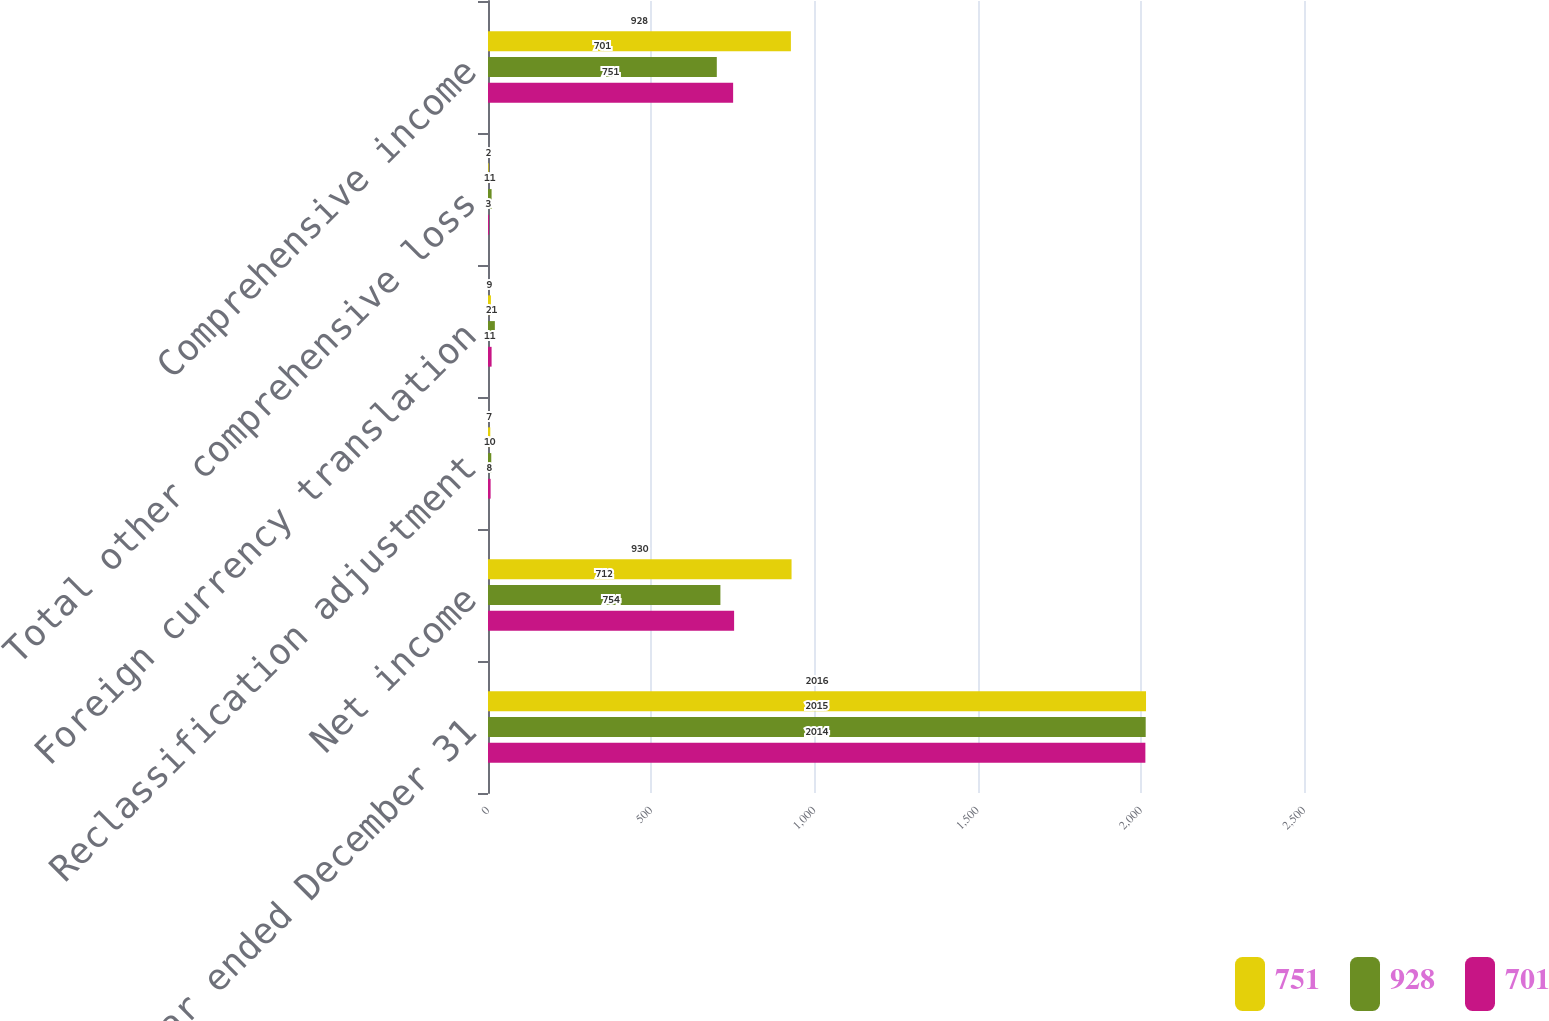<chart> <loc_0><loc_0><loc_500><loc_500><stacked_bar_chart><ecel><fcel>Year ended December 31<fcel>Net income<fcel>Reclassification adjustment<fcel>Foreign currency translation<fcel>Total other comprehensive loss<fcel>Comprehensive income<nl><fcel>751<fcel>2016<fcel>930<fcel>7<fcel>9<fcel>2<fcel>928<nl><fcel>928<fcel>2015<fcel>712<fcel>10<fcel>21<fcel>11<fcel>701<nl><fcel>701<fcel>2014<fcel>754<fcel>8<fcel>11<fcel>3<fcel>751<nl></chart> 